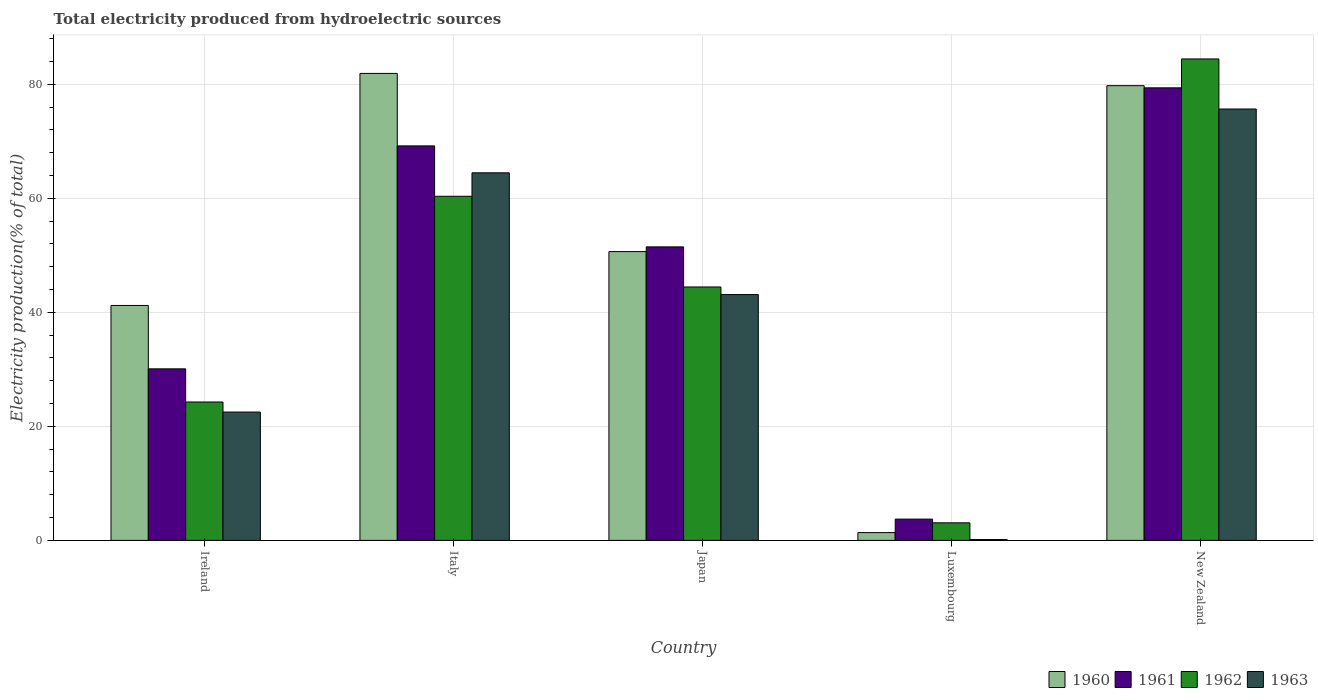How many groups of bars are there?
Your answer should be compact. 5. How many bars are there on the 3rd tick from the left?
Offer a terse response. 4. How many bars are there on the 2nd tick from the right?
Provide a short and direct response. 4. In how many cases, is the number of bars for a given country not equal to the number of legend labels?
Your answer should be compact. 0. What is the total electricity produced in 1963 in New Zealand?
Give a very brief answer. 75.66. Across all countries, what is the maximum total electricity produced in 1963?
Your response must be concise. 75.66. Across all countries, what is the minimum total electricity produced in 1962?
Your answer should be compact. 3.08. In which country was the total electricity produced in 1962 maximum?
Ensure brevity in your answer.  New Zealand. In which country was the total electricity produced in 1962 minimum?
Offer a very short reply. Luxembourg. What is the total total electricity produced in 1960 in the graph?
Keep it short and to the point. 254.87. What is the difference between the total electricity produced in 1961 in Ireland and that in New Zealand?
Make the answer very short. -49.29. What is the difference between the total electricity produced in 1960 in Ireland and the total electricity produced in 1962 in Japan?
Give a very brief answer. -3.24. What is the average total electricity produced in 1961 per country?
Your answer should be very brief. 46.77. What is the difference between the total electricity produced of/in 1963 and total electricity produced of/in 1962 in Ireland?
Offer a terse response. -1.76. What is the ratio of the total electricity produced in 1963 in Japan to that in Luxembourg?
Provide a short and direct response. 292.1. Is the difference between the total electricity produced in 1963 in Japan and New Zealand greater than the difference between the total electricity produced in 1962 in Japan and New Zealand?
Give a very brief answer. Yes. What is the difference between the highest and the second highest total electricity produced in 1962?
Make the answer very short. 24.08. What is the difference between the highest and the lowest total electricity produced in 1963?
Offer a terse response. 75.51. What does the 3rd bar from the left in Luxembourg represents?
Your answer should be compact. 1962. How many countries are there in the graph?
Offer a very short reply. 5. Does the graph contain grids?
Make the answer very short. Yes. Where does the legend appear in the graph?
Ensure brevity in your answer.  Bottom right. What is the title of the graph?
Give a very brief answer. Total electricity produced from hydroelectric sources. What is the label or title of the Y-axis?
Offer a terse response. Electricity production(% of total). What is the Electricity production(% of total) of 1960 in Ireland?
Your response must be concise. 41.2. What is the Electricity production(% of total) in 1961 in Ireland?
Give a very brief answer. 30.09. What is the Electricity production(% of total) in 1962 in Ireland?
Keep it short and to the point. 24.27. What is the Electricity production(% of total) of 1963 in Ireland?
Your response must be concise. 22.51. What is the Electricity production(% of total) of 1960 in Italy?
Your answer should be compact. 81.9. What is the Electricity production(% of total) of 1961 in Italy?
Make the answer very short. 69.19. What is the Electricity production(% of total) of 1962 in Italy?
Make the answer very short. 60.35. What is the Electricity production(% of total) in 1963 in Italy?
Your answer should be compact. 64.47. What is the Electricity production(% of total) in 1960 in Japan?
Your response must be concise. 50.65. What is the Electricity production(% of total) of 1961 in Japan?
Your answer should be compact. 51.48. What is the Electricity production(% of total) of 1962 in Japan?
Ensure brevity in your answer.  44.44. What is the Electricity production(% of total) in 1963 in Japan?
Offer a terse response. 43.11. What is the Electricity production(% of total) of 1960 in Luxembourg?
Give a very brief answer. 1.37. What is the Electricity production(% of total) of 1961 in Luxembourg?
Give a very brief answer. 3.73. What is the Electricity production(% of total) of 1962 in Luxembourg?
Your answer should be compact. 3.08. What is the Electricity production(% of total) of 1963 in Luxembourg?
Provide a succinct answer. 0.15. What is the Electricity production(% of total) in 1960 in New Zealand?
Your response must be concise. 79.75. What is the Electricity production(% of total) in 1961 in New Zealand?
Keep it short and to the point. 79.37. What is the Electricity production(% of total) in 1962 in New Zealand?
Provide a short and direct response. 84.44. What is the Electricity production(% of total) of 1963 in New Zealand?
Provide a succinct answer. 75.66. Across all countries, what is the maximum Electricity production(% of total) in 1960?
Your answer should be compact. 81.9. Across all countries, what is the maximum Electricity production(% of total) in 1961?
Ensure brevity in your answer.  79.37. Across all countries, what is the maximum Electricity production(% of total) of 1962?
Your answer should be very brief. 84.44. Across all countries, what is the maximum Electricity production(% of total) in 1963?
Offer a very short reply. 75.66. Across all countries, what is the minimum Electricity production(% of total) of 1960?
Provide a succinct answer. 1.37. Across all countries, what is the minimum Electricity production(% of total) in 1961?
Offer a terse response. 3.73. Across all countries, what is the minimum Electricity production(% of total) in 1962?
Give a very brief answer. 3.08. Across all countries, what is the minimum Electricity production(% of total) in 1963?
Ensure brevity in your answer.  0.15. What is the total Electricity production(% of total) in 1960 in the graph?
Give a very brief answer. 254.87. What is the total Electricity production(% of total) of 1961 in the graph?
Your response must be concise. 233.85. What is the total Electricity production(% of total) in 1962 in the graph?
Give a very brief answer. 216.59. What is the total Electricity production(% of total) in 1963 in the graph?
Make the answer very short. 205.9. What is the difference between the Electricity production(% of total) of 1960 in Ireland and that in Italy?
Offer a very short reply. -40.7. What is the difference between the Electricity production(% of total) of 1961 in Ireland and that in Italy?
Ensure brevity in your answer.  -39.1. What is the difference between the Electricity production(% of total) in 1962 in Ireland and that in Italy?
Give a very brief answer. -36.08. What is the difference between the Electricity production(% of total) of 1963 in Ireland and that in Italy?
Your response must be concise. -41.96. What is the difference between the Electricity production(% of total) of 1960 in Ireland and that in Japan?
Give a very brief answer. -9.45. What is the difference between the Electricity production(% of total) in 1961 in Ireland and that in Japan?
Offer a very short reply. -21.39. What is the difference between the Electricity production(% of total) of 1962 in Ireland and that in Japan?
Offer a terse response. -20.17. What is the difference between the Electricity production(% of total) in 1963 in Ireland and that in Japan?
Give a very brief answer. -20.61. What is the difference between the Electricity production(% of total) in 1960 in Ireland and that in Luxembourg?
Offer a terse response. 39.84. What is the difference between the Electricity production(% of total) in 1961 in Ireland and that in Luxembourg?
Ensure brevity in your answer.  26.36. What is the difference between the Electricity production(% of total) in 1962 in Ireland and that in Luxembourg?
Provide a succinct answer. 21.19. What is the difference between the Electricity production(% of total) of 1963 in Ireland and that in Luxembourg?
Ensure brevity in your answer.  22.36. What is the difference between the Electricity production(% of total) in 1960 in Ireland and that in New Zealand?
Provide a short and direct response. -38.55. What is the difference between the Electricity production(% of total) of 1961 in Ireland and that in New Zealand?
Make the answer very short. -49.29. What is the difference between the Electricity production(% of total) of 1962 in Ireland and that in New Zealand?
Provide a succinct answer. -60.17. What is the difference between the Electricity production(% of total) in 1963 in Ireland and that in New Zealand?
Your answer should be compact. -53.15. What is the difference between the Electricity production(% of total) of 1960 in Italy and that in Japan?
Provide a succinct answer. 31.25. What is the difference between the Electricity production(% of total) in 1961 in Italy and that in Japan?
Offer a very short reply. 17.71. What is the difference between the Electricity production(% of total) of 1962 in Italy and that in Japan?
Keep it short and to the point. 15.91. What is the difference between the Electricity production(% of total) of 1963 in Italy and that in Japan?
Keep it short and to the point. 21.35. What is the difference between the Electricity production(% of total) of 1960 in Italy and that in Luxembourg?
Make the answer very short. 80.53. What is the difference between the Electricity production(% of total) of 1961 in Italy and that in Luxembourg?
Give a very brief answer. 65.46. What is the difference between the Electricity production(% of total) in 1962 in Italy and that in Luxembourg?
Keep it short and to the point. 57.27. What is the difference between the Electricity production(% of total) in 1963 in Italy and that in Luxembourg?
Your answer should be very brief. 64.32. What is the difference between the Electricity production(% of total) in 1960 in Italy and that in New Zealand?
Provide a succinct answer. 2.15. What is the difference between the Electricity production(% of total) of 1961 in Italy and that in New Zealand?
Offer a terse response. -10.18. What is the difference between the Electricity production(% of total) in 1962 in Italy and that in New Zealand?
Give a very brief answer. -24.08. What is the difference between the Electricity production(% of total) in 1963 in Italy and that in New Zealand?
Your answer should be very brief. -11.19. What is the difference between the Electricity production(% of total) of 1960 in Japan and that in Luxembourg?
Your response must be concise. 49.28. What is the difference between the Electricity production(% of total) of 1961 in Japan and that in Luxembourg?
Your answer should be compact. 47.75. What is the difference between the Electricity production(% of total) in 1962 in Japan and that in Luxembourg?
Offer a terse response. 41.36. What is the difference between the Electricity production(% of total) of 1963 in Japan and that in Luxembourg?
Your answer should be very brief. 42.97. What is the difference between the Electricity production(% of total) of 1960 in Japan and that in New Zealand?
Your response must be concise. -29.1. What is the difference between the Electricity production(% of total) of 1961 in Japan and that in New Zealand?
Offer a very short reply. -27.9. What is the difference between the Electricity production(% of total) of 1962 in Japan and that in New Zealand?
Offer a very short reply. -39.99. What is the difference between the Electricity production(% of total) in 1963 in Japan and that in New Zealand?
Keep it short and to the point. -32.54. What is the difference between the Electricity production(% of total) in 1960 in Luxembourg and that in New Zealand?
Offer a very short reply. -78.38. What is the difference between the Electricity production(% of total) in 1961 in Luxembourg and that in New Zealand?
Provide a short and direct response. -75.64. What is the difference between the Electricity production(% of total) in 1962 in Luxembourg and that in New Zealand?
Your answer should be compact. -81.36. What is the difference between the Electricity production(% of total) of 1963 in Luxembourg and that in New Zealand?
Offer a very short reply. -75.51. What is the difference between the Electricity production(% of total) of 1960 in Ireland and the Electricity production(% of total) of 1961 in Italy?
Your response must be concise. -27.99. What is the difference between the Electricity production(% of total) in 1960 in Ireland and the Electricity production(% of total) in 1962 in Italy?
Offer a terse response. -19.15. What is the difference between the Electricity production(% of total) of 1960 in Ireland and the Electricity production(% of total) of 1963 in Italy?
Your answer should be very brief. -23.27. What is the difference between the Electricity production(% of total) in 1961 in Ireland and the Electricity production(% of total) in 1962 in Italy?
Provide a succinct answer. -30.27. What is the difference between the Electricity production(% of total) of 1961 in Ireland and the Electricity production(% of total) of 1963 in Italy?
Your answer should be very brief. -34.38. What is the difference between the Electricity production(% of total) in 1962 in Ireland and the Electricity production(% of total) in 1963 in Italy?
Your answer should be very brief. -40.2. What is the difference between the Electricity production(% of total) of 1960 in Ireland and the Electricity production(% of total) of 1961 in Japan?
Provide a succinct answer. -10.27. What is the difference between the Electricity production(% of total) of 1960 in Ireland and the Electricity production(% of total) of 1962 in Japan?
Your response must be concise. -3.24. What is the difference between the Electricity production(% of total) in 1960 in Ireland and the Electricity production(% of total) in 1963 in Japan?
Make the answer very short. -1.91. What is the difference between the Electricity production(% of total) in 1961 in Ireland and the Electricity production(% of total) in 1962 in Japan?
Offer a terse response. -14.36. What is the difference between the Electricity production(% of total) of 1961 in Ireland and the Electricity production(% of total) of 1963 in Japan?
Offer a terse response. -13.03. What is the difference between the Electricity production(% of total) of 1962 in Ireland and the Electricity production(% of total) of 1963 in Japan?
Keep it short and to the point. -18.84. What is the difference between the Electricity production(% of total) of 1960 in Ireland and the Electricity production(% of total) of 1961 in Luxembourg?
Your answer should be compact. 37.47. What is the difference between the Electricity production(% of total) in 1960 in Ireland and the Electricity production(% of total) in 1962 in Luxembourg?
Keep it short and to the point. 38.12. What is the difference between the Electricity production(% of total) in 1960 in Ireland and the Electricity production(% of total) in 1963 in Luxembourg?
Give a very brief answer. 41.05. What is the difference between the Electricity production(% of total) of 1961 in Ireland and the Electricity production(% of total) of 1962 in Luxembourg?
Your answer should be very brief. 27. What is the difference between the Electricity production(% of total) of 1961 in Ireland and the Electricity production(% of total) of 1963 in Luxembourg?
Keep it short and to the point. 29.94. What is the difference between the Electricity production(% of total) of 1962 in Ireland and the Electricity production(% of total) of 1963 in Luxembourg?
Your answer should be compact. 24.12. What is the difference between the Electricity production(% of total) in 1960 in Ireland and the Electricity production(% of total) in 1961 in New Zealand?
Ensure brevity in your answer.  -38.17. What is the difference between the Electricity production(% of total) of 1960 in Ireland and the Electricity production(% of total) of 1962 in New Zealand?
Give a very brief answer. -43.24. What is the difference between the Electricity production(% of total) of 1960 in Ireland and the Electricity production(% of total) of 1963 in New Zealand?
Offer a terse response. -34.46. What is the difference between the Electricity production(% of total) of 1961 in Ireland and the Electricity production(% of total) of 1962 in New Zealand?
Your response must be concise. -54.35. What is the difference between the Electricity production(% of total) in 1961 in Ireland and the Electricity production(% of total) in 1963 in New Zealand?
Provide a short and direct response. -45.57. What is the difference between the Electricity production(% of total) of 1962 in Ireland and the Electricity production(% of total) of 1963 in New Zealand?
Your response must be concise. -51.39. What is the difference between the Electricity production(% of total) of 1960 in Italy and the Electricity production(% of total) of 1961 in Japan?
Give a very brief answer. 30.42. What is the difference between the Electricity production(% of total) of 1960 in Italy and the Electricity production(% of total) of 1962 in Japan?
Give a very brief answer. 37.46. What is the difference between the Electricity production(% of total) of 1960 in Italy and the Electricity production(% of total) of 1963 in Japan?
Give a very brief answer. 38.79. What is the difference between the Electricity production(% of total) in 1961 in Italy and the Electricity production(% of total) in 1962 in Japan?
Offer a very short reply. 24.75. What is the difference between the Electricity production(% of total) of 1961 in Italy and the Electricity production(% of total) of 1963 in Japan?
Your response must be concise. 26.08. What is the difference between the Electricity production(% of total) of 1962 in Italy and the Electricity production(% of total) of 1963 in Japan?
Your answer should be compact. 17.24. What is the difference between the Electricity production(% of total) of 1960 in Italy and the Electricity production(% of total) of 1961 in Luxembourg?
Your answer should be very brief. 78.17. What is the difference between the Electricity production(% of total) in 1960 in Italy and the Electricity production(% of total) in 1962 in Luxembourg?
Make the answer very short. 78.82. What is the difference between the Electricity production(% of total) of 1960 in Italy and the Electricity production(% of total) of 1963 in Luxembourg?
Your answer should be very brief. 81.75. What is the difference between the Electricity production(% of total) in 1961 in Italy and the Electricity production(% of total) in 1962 in Luxembourg?
Offer a terse response. 66.11. What is the difference between the Electricity production(% of total) in 1961 in Italy and the Electricity production(% of total) in 1963 in Luxembourg?
Make the answer very short. 69.04. What is the difference between the Electricity production(% of total) of 1962 in Italy and the Electricity production(% of total) of 1963 in Luxembourg?
Provide a succinct answer. 60.21. What is the difference between the Electricity production(% of total) of 1960 in Italy and the Electricity production(% of total) of 1961 in New Zealand?
Provide a succinct answer. 2.53. What is the difference between the Electricity production(% of total) of 1960 in Italy and the Electricity production(% of total) of 1962 in New Zealand?
Offer a terse response. -2.54. What is the difference between the Electricity production(% of total) of 1960 in Italy and the Electricity production(% of total) of 1963 in New Zealand?
Your answer should be very brief. 6.24. What is the difference between the Electricity production(% of total) in 1961 in Italy and the Electricity production(% of total) in 1962 in New Zealand?
Ensure brevity in your answer.  -15.25. What is the difference between the Electricity production(% of total) in 1961 in Italy and the Electricity production(% of total) in 1963 in New Zealand?
Keep it short and to the point. -6.47. What is the difference between the Electricity production(% of total) of 1962 in Italy and the Electricity production(% of total) of 1963 in New Zealand?
Keep it short and to the point. -15.3. What is the difference between the Electricity production(% of total) of 1960 in Japan and the Electricity production(% of total) of 1961 in Luxembourg?
Provide a succinct answer. 46.92. What is the difference between the Electricity production(% of total) of 1960 in Japan and the Electricity production(% of total) of 1962 in Luxembourg?
Make the answer very short. 47.57. What is the difference between the Electricity production(% of total) of 1960 in Japan and the Electricity production(% of total) of 1963 in Luxembourg?
Keep it short and to the point. 50.5. What is the difference between the Electricity production(% of total) of 1961 in Japan and the Electricity production(% of total) of 1962 in Luxembourg?
Make the answer very short. 48.39. What is the difference between the Electricity production(% of total) of 1961 in Japan and the Electricity production(% of total) of 1963 in Luxembourg?
Keep it short and to the point. 51.33. What is the difference between the Electricity production(% of total) in 1962 in Japan and the Electricity production(% of total) in 1963 in Luxembourg?
Make the answer very short. 44.3. What is the difference between the Electricity production(% of total) of 1960 in Japan and the Electricity production(% of total) of 1961 in New Zealand?
Your response must be concise. -28.72. What is the difference between the Electricity production(% of total) of 1960 in Japan and the Electricity production(% of total) of 1962 in New Zealand?
Provide a succinct answer. -33.79. What is the difference between the Electricity production(% of total) of 1960 in Japan and the Electricity production(% of total) of 1963 in New Zealand?
Offer a very short reply. -25.01. What is the difference between the Electricity production(% of total) of 1961 in Japan and the Electricity production(% of total) of 1962 in New Zealand?
Make the answer very short. -32.96. What is the difference between the Electricity production(% of total) of 1961 in Japan and the Electricity production(% of total) of 1963 in New Zealand?
Your answer should be compact. -24.18. What is the difference between the Electricity production(% of total) of 1962 in Japan and the Electricity production(% of total) of 1963 in New Zealand?
Offer a terse response. -31.21. What is the difference between the Electricity production(% of total) of 1960 in Luxembourg and the Electricity production(% of total) of 1961 in New Zealand?
Your response must be concise. -78.01. What is the difference between the Electricity production(% of total) in 1960 in Luxembourg and the Electricity production(% of total) in 1962 in New Zealand?
Your answer should be compact. -83.07. What is the difference between the Electricity production(% of total) in 1960 in Luxembourg and the Electricity production(% of total) in 1963 in New Zealand?
Keep it short and to the point. -74.29. What is the difference between the Electricity production(% of total) of 1961 in Luxembourg and the Electricity production(% of total) of 1962 in New Zealand?
Your response must be concise. -80.71. What is the difference between the Electricity production(% of total) in 1961 in Luxembourg and the Electricity production(% of total) in 1963 in New Zealand?
Your answer should be compact. -71.93. What is the difference between the Electricity production(% of total) of 1962 in Luxembourg and the Electricity production(% of total) of 1963 in New Zealand?
Offer a terse response. -72.58. What is the average Electricity production(% of total) of 1960 per country?
Give a very brief answer. 50.97. What is the average Electricity production(% of total) in 1961 per country?
Provide a succinct answer. 46.77. What is the average Electricity production(% of total) of 1962 per country?
Offer a terse response. 43.32. What is the average Electricity production(% of total) in 1963 per country?
Offer a very short reply. 41.18. What is the difference between the Electricity production(% of total) of 1960 and Electricity production(% of total) of 1961 in Ireland?
Keep it short and to the point. 11.12. What is the difference between the Electricity production(% of total) of 1960 and Electricity production(% of total) of 1962 in Ireland?
Ensure brevity in your answer.  16.93. What is the difference between the Electricity production(% of total) in 1960 and Electricity production(% of total) in 1963 in Ireland?
Make the answer very short. 18.69. What is the difference between the Electricity production(% of total) in 1961 and Electricity production(% of total) in 1962 in Ireland?
Your response must be concise. 5.81. What is the difference between the Electricity production(% of total) of 1961 and Electricity production(% of total) of 1963 in Ireland?
Provide a short and direct response. 7.58. What is the difference between the Electricity production(% of total) in 1962 and Electricity production(% of total) in 1963 in Ireland?
Make the answer very short. 1.76. What is the difference between the Electricity production(% of total) of 1960 and Electricity production(% of total) of 1961 in Italy?
Keep it short and to the point. 12.71. What is the difference between the Electricity production(% of total) in 1960 and Electricity production(% of total) in 1962 in Italy?
Keep it short and to the point. 21.55. What is the difference between the Electricity production(% of total) in 1960 and Electricity production(% of total) in 1963 in Italy?
Your answer should be very brief. 17.43. What is the difference between the Electricity production(% of total) in 1961 and Electricity production(% of total) in 1962 in Italy?
Provide a short and direct response. 8.84. What is the difference between the Electricity production(% of total) in 1961 and Electricity production(% of total) in 1963 in Italy?
Your answer should be very brief. 4.72. What is the difference between the Electricity production(% of total) in 1962 and Electricity production(% of total) in 1963 in Italy?
Provide a succinct answer. -4.11. What is the difference between the Electricity production(% of total) in 1960 and Electricity production(% of total) in 1961 in Japan?
Offer a terse response. -0.83. What is the difference between the Electricity production(% of total) in 1960 and Electricity production(% of total) in 1962 in Japan?
Keep it short and to the point. 6.2. What is the difference between the Electricity production(% of total) of 1960 and Electricity production(% of total) of 1963 in Japan?
Make the answer very short. 7.54. What is the difference between the Electricity production(% of total) in 1961 and Electricity production(% of total) in 1962 in Japan?
Your answer should be very brief. 7.03. What is the difference between the Electricity production(% of total) in 1961 and Electricity production(% of total) in 1963 in Japan?
Provide a succinct answer. 8.36. What is the difference between the Electricity production(% of total) of 1962 and Electricity production(% of total) of 1963 in Japan?
Provide a short and direct response. 1.33. What is the difference between the Electricity production(% of total) in 1960 and Electricity production(% of total) in 1961 in Luxembourg?
Your response must be concise. -2.36. What is the difference between the Electricity production(% of total) of 1960 and Electricity production(% of total) of 1962 in Luxembourg?
Offer a very short reply. -1.72. What is the difference between the Electricity production(% of total) in 1960 and Electricity production(% of total) in 1963 in Luxembourg?
Keep it short and to the point. 1.22. What is the difference between the Electricity production(% of total) in 1961 and Electricity production(% of total) in 1962 in Luxembourg?
Your answer should be very brief. 0.65. What is the difference between the Electricity production(% of total) in 1961 and Electricity production(% of total) in 1963 in Luxembourg?
Offer a terse response. 3.58. What is the difference between the Electricity production(% of total) in 1962 and Electricity production(% of total) in 1963 in Luxembourg?
Your answer should be compact. 2.93. What is the difference between the Electricity production(% of total) of 1960 and Electricity production(% of total) of 1961 in New Zealand?
Provide a short and direct response. 0.38. What is the difference between the Electricity production(% of total) in 1960 and Electricity production(% of total) in 1962 in New Zealand?
Your response must be concise. -4.69. What is the difference between the Electricity production(% of total) of 1960 and Electricity production(% of total) of 1963 in New Zealand?
Your answer should be compact. 4.09. What is the difference between the Electricity production(% of total) in 1961 and Electricity production(% of total) in 1962 in New Zealand?
Your response must be concise. -5.07. What is the difference between the Electricity production(% of total) in 1961 and Electricity production(% of total) in 1963 in New Zealand?
Make the answer very short. 3.71. What is the difference between the Electricity production(% of total) in 1962 and Electricity production(% of total) in 1963 in New Zealand?
Provide a short and direct response. 8.78. What is the ratio of the Electricity production(% of total) of 1960 in Ireland to that in Italy?
Make the answer very short. 0.5. What is the ratio of the Electricity production(% of total) of 1961 in Ireland to that in Italy?
Provide a succinct answer. 0.43. What is the ratio of the Electricity production(% of total) of 1962 in Ireland to that in Italy?
Provide a short and direct response. 0.4. What is the ratio of the Electricity production(% of total) in 1963 in Ireland to that in Italy?
Keep it short and to the point. 0.35. What is the ratio of the Electricity production(% of total) in 1960 in Ireland to that in Japan?
Provide a succinct answer. 0.81. What is the ratio of the Electricity production(% of total) in 1961 in Ireland to that in Japan?
Give a very brief answer. 0.58. What is the ratio of the Electricity production(% of total) of 1962 in Ireland to that in Japan?
Ensure brevity in your answer.  0.55. What is the ratio of the Electricity production(% of total) of 1963 in Ireland to that in Japan?
Keep it short and to the point. 0.52. What is the ratio of the Electricity production(% of total) in 1960 in Ireland to that in Luxembourg?
Provide a succinct answer. 30.16. What is the ratio of the Electricity production(% of total) of 1961 in Ireland to that in Luxembourg?
Offer a very short reply. 8.07. What is the ratio of the Electricity production(% of total) in 1962 in Ireland to that in Luxembourg?
Your answer should be very brief. 7.88. What is the ratio of the Electricity production(% of total) in 1963 in Ireland to that in Luxembourg?
Your answer should be very brief. 152.5. What is the ratio of the Electricity production(% of total) in 1960 in Ireland to that in New Zealand?
Offer a terse response. 0.52. What is the ratio of the Electricity production(% of total) of 1961 in Ireland to that in New Zealand?
Keep it short and to the point. 0.38. What is the ratio of the Electricity production(% of total) of 1962 in Ireland to that in New Zealand?
Provide a short and direct response. 0.29. What is the ratio of the Electricity production(% of total) of 1963 in Ireland to that in New Zealand?
Offer a terse response. 0.3. What is the ratio of the Electricity production(% of total) of 1960 in Italy to that in Japan?
Provide a short and direct response. 1.62. What is the ratio of the Electricity production(% of total) in 1961 in Italy to that in Japan?
Offer a terse response. 1.34. What is the ratio of the Electricity production(% of total) in 1962 in Italy to that in Japan?
Your response must be concise. 1.36. What is the ratio of the Electricity production(% of total) in 1963 in Italy to that in Japan?
Keep it short and to the point. 1.5. What is the ratio of the Electricity production(% of total) in 1960 in Italy to that in Luxembourg?
Your response must be concise. 59.95. What is the ratio of the Electricity production(% of total) of 1961 in Italy to that in Luxembourg?
Your answer should be very brief. 18.55. What is the ratio of the Electricity production(% of total) of 1962 in Italy to that in Luxembourg?
Provide a succinct answer. 19.58. What is the ratio of the Electricity production(% of total) of 1963 in Italy to that in Luxembourg?
Provide a short and direct response. 436.77. What is the ratio of the Electricity production(% of total) in 1960 in Italy to that in New Zealand?
Offer a very short reply. 1.03. What is the ratio of the Electricity production(% of total) of 1961 in Italy to that in New Zealand?
Make the answer very short. 0.87. What is the ratio of the Electricity production(% of total) in 1962 in Italy to that in New Zealand?
Offer a terse response. 0.71. What is the ratio of the Electricity production(% of total) in 1963 in Italy to that in New Zealand?
Offer a terse response. 0.85. What is the ratio of the Electricity production(% of total) of 1960 in Japan to that in Luxembourg?
Keep it short and to the point. 37.08. What is the ratio of the Electricity production(% of total) of 1961 in Japan to that in Luxembourg?
Provide a short and direct response. 13.8. What is the ratio of the Electricity production(% of total) of 1962 in Japan to that in Luxembourg?
Your response must be concise. 14.42. What is the ratio of the Electricity production(% of total) in 1963 in Japan to that in Luxembourg?
Keep it short and to the point. 292.1. What is the ratio of the Electricity production(% of total) in 1960 in Japan to that in New Zealand?
Provide a short and direct response. 0.64. What is the ratio of the Electricity production(% of total) in 1961 in Japan to that in New Zealand?
Make the answer very short. 0.65. What is the ratio of the Electricity production(% of total) in 1962 in Japan to that in New Zealand?
Your answer should be compact. 0.53. What is the ratio of the Electricity production(% of total) of 1963 in Japan to that in New Zealand?
Give a very brief answer. 0.57. What is the ratio of the Electricity production(% of total) in 1960 in Luxembourg to that in New Zealand?
Ensure brevity in your answer.  0.02. What is the ratio of the Electricity production(% of total) in 1961 in Luxembourg to that in New Zealand?
Your answer should be compact. 0.05. What is the ratio of the Electricity production(% of total) of 1962 in Luxembourg to that in New Zealand?
Keep it short and to the point. 0.04. What is the ratio of the Electricity production(% of total) of 1963 in Luxembourg to that in New Zealand?
Ensure brevity in your answer.  0. What is the difference between the highest and the second highest Electricity production(% of total) of 1960?
Provide a short and direct response. 2.15. What is the difference between the highest and the second highest Electricity production(% of total) of 1961?
Your answer should be very brief. 10.18. What is the difference between the highest and the second highest Electricity production(% of total) of 1962?
Your response must be concise. 24.08. What is the difference between the highest and the second highest Electricity production(% of total) in 1963?
Keep it short and to the point. 11.19. What is the difference between the highest and the lowest Electricity production(% of total) in 1960?
Your answer should be very brief. 80.53. What is the difference between the highest and the lowest Electricity production(% of total) of 1961?
Your answer should be very brief. 75.64. What is the difference between the highest and the lowest Electricity production(% of total) in 1962?
Provide a short and direct response. 81.36. What is the difference between the highest and the lowest Electricity production(% of total) of 1963?
Provide a succinct answer. 75.51. 